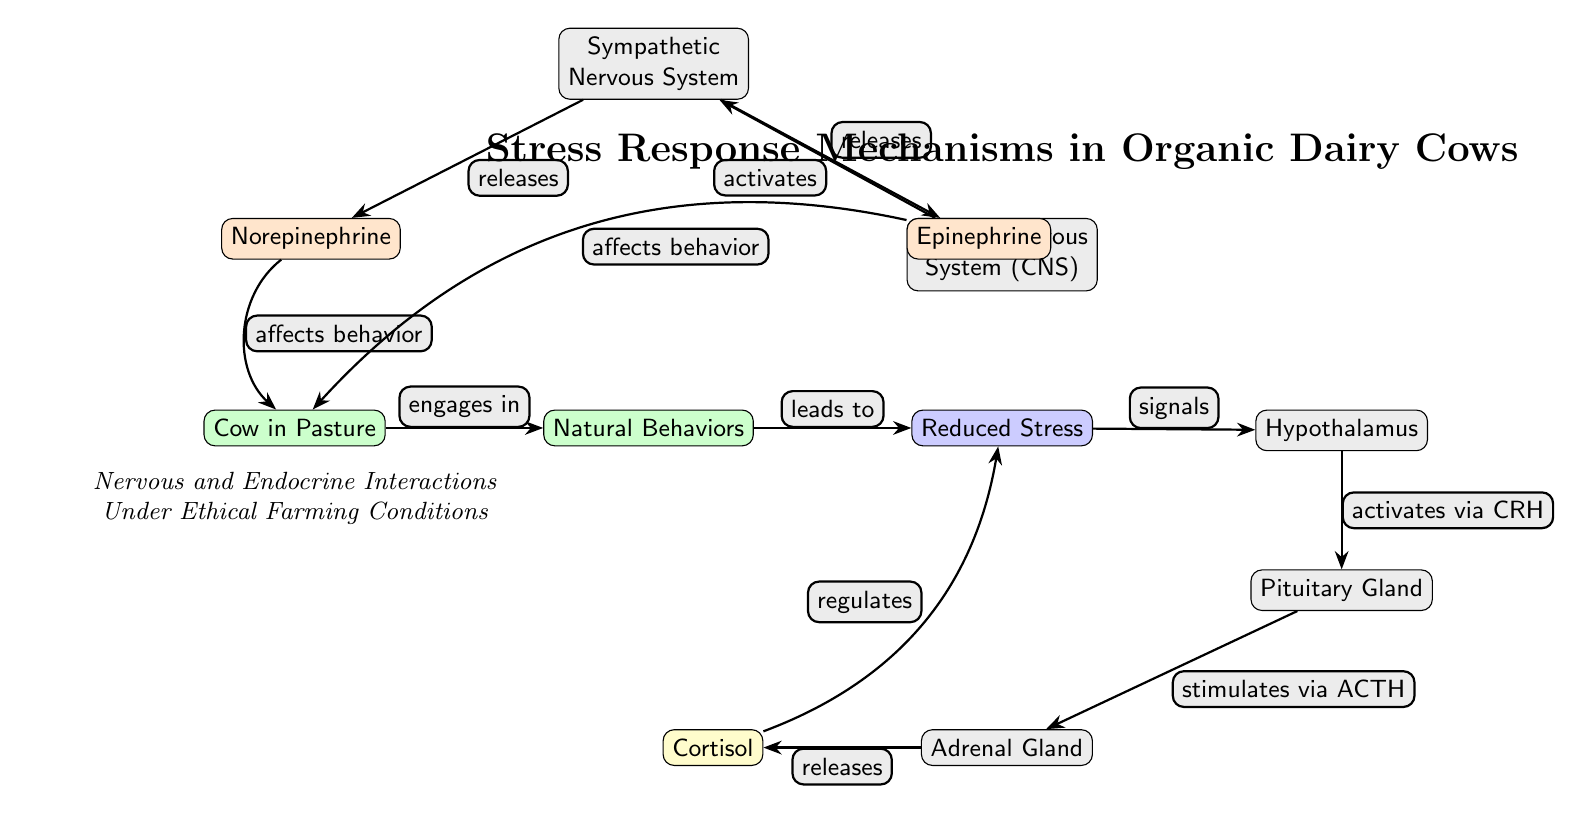What behavior does the cow engage in while in pasture? The diagram indicates that the cow engages in "Natural Behaviors" while in the pasture. It is directly mentioned in the relationship between the nodes "Cow in Pasture" and "Natural Behaviors".
Answer: Natural Behaviors What does reduced stress signal to in the diagram? The diagram shows that "Reduced Stress" signals the "Hypothalamus". This relationship is marked with an arrow indicating a direct connection between these two nodes.
Answer: Hypothalamus How many hormones are associated with the sympathetic nervous system? The sympathetic nervous system releases two hormones: "Norepinephrine" and "Epinephrine". The diagram clearly identifies these two nodes stemming from the sympathetic nervous system node.
Answer: Two What regulates cortisol levels according to the diagram? The diagram states that "Cortisol" regulates "Reduced Stress". This connection is indicated by the arrow that bends right from the cortisol node to the reduced stress node, showing a regulatory relationship.
Answer: Reduced Stress What activates the sympathetic nervous system in the diagram? The "Central Nervous System (CNS)" activates the "Sympathetic Nervous System" according to the arrow indicating the flow of information depicted in the diagram. This establishes a causal relationship between the CNS and the sympathetic nervous system.
Answer: Central Nervous System Which gland is stimulated by the pituitary gland and what does it release? The "Pituitary Gland" stimulates the "Adrenal Gland" via ACTH (Adrenocorticotropic hormone), and the adrenal gland releases "Cortisol". This pathway from the pituitary gland to the adrenal gland and the action of cortisol is clearly outlined in the diagram.
Answer: Cortisol What effect does norepinephrine have on the cow in the pasture? "Norepinephrine" affects the behavior of the "Cow in Pasture". The diagram directly shows this relationship with an arrow indicating that norepinephrine influences how the cow behaves while in the pasture.
Answer: Behavior What is the purpose of the stress response mechanisms in dairy cows? The overall purpose highlighted in the diagram is to achieve "Reduced Stress". The series of relationships culminates in this outcome, demonstrating how various factors and hormonal responses contribute to stress reduction.
Answer: Reduced Stress How does the activation of the hypothalamus occur in the diagram? Activation of the "Hypothalamus" occurs via "CRH" (Corticotropin-Releasing Hormone) as stimulated by "Reduced Stress". This flow can be traced directly in the diagram from reduced stress to hypothalamus activation.
Answer: Via CRH 